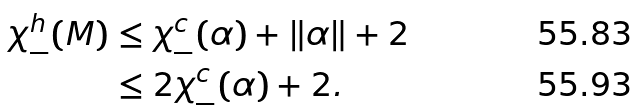<formula> <loc_0><loc_0><loc_500><loc_500>\chi _ { - } ^ { h } ( M ) & \leq \chi _ { - } ^ { c } ( \alpha ) + \| \alpha \| + 2 \\ & \leq 2 \chi _ { - } ^ { c } ( \alpha ) + 2 .</formula> 